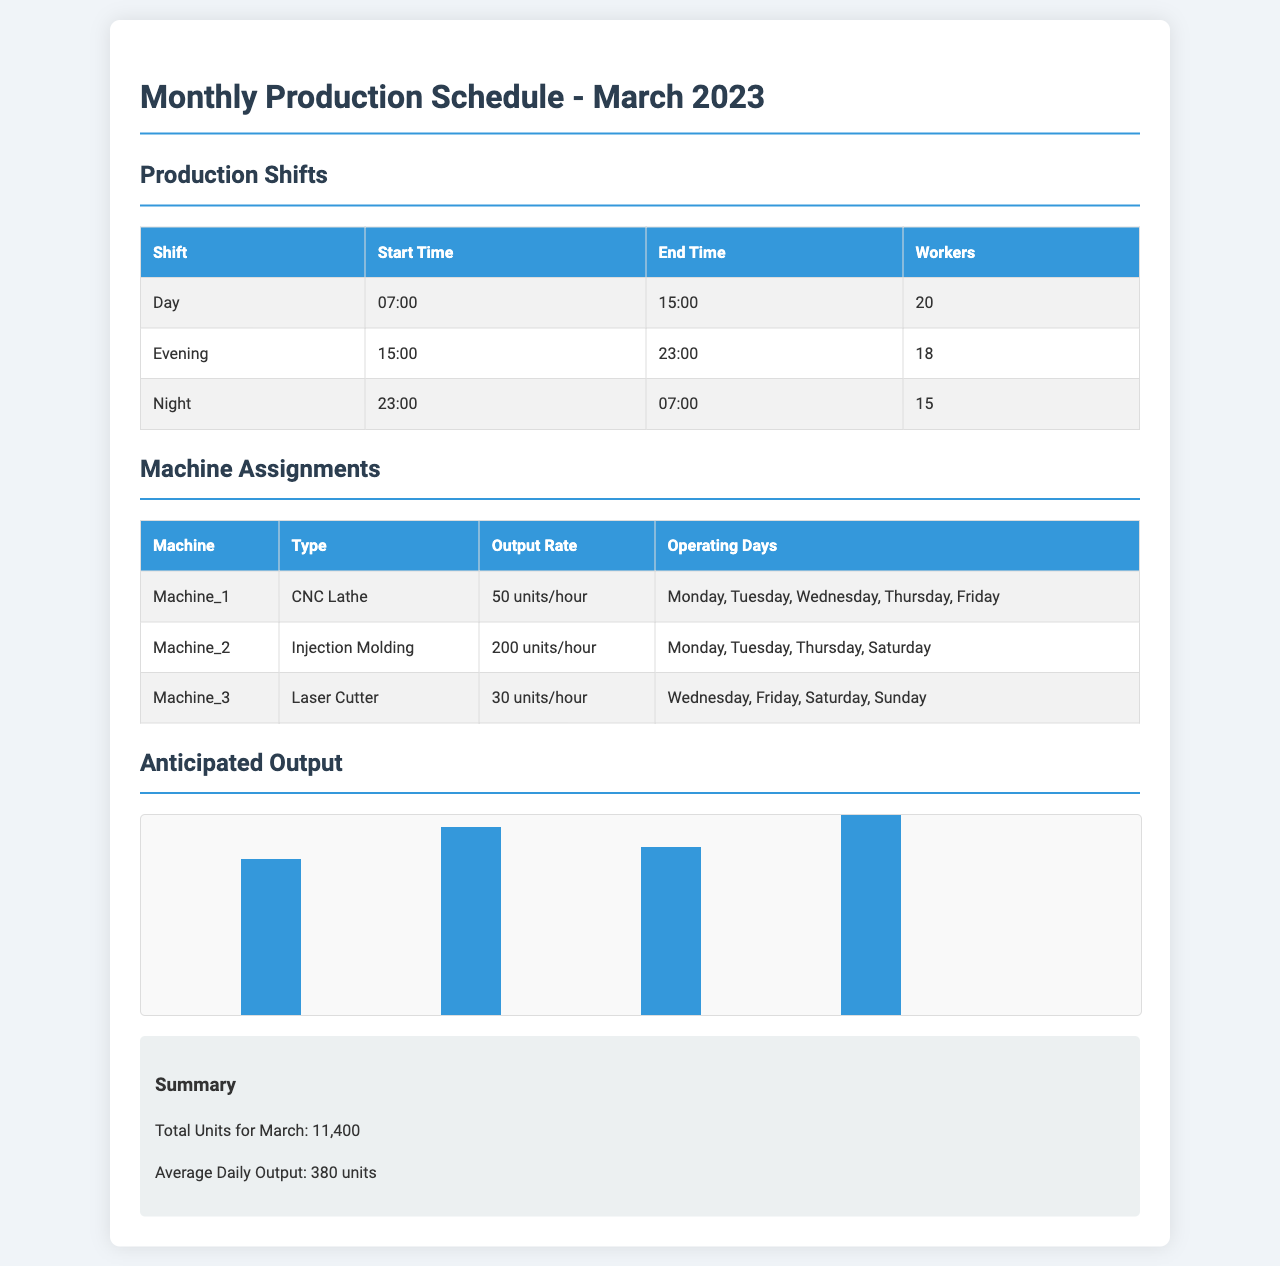What is the start time of the Day shift? The start time of the Day shift is listed in the Production Shifts section.
Answer: 07:00 How many workers are assigned to the Evening shift? The number of workers for the Evening shift is provided in the Production Shifts table.
Answer: 18 What is the output rate of Machine_2? The output rate for Machine_2 is found in the Machine Assignments table.
Answer: 200 units/hour On which days does Machine_3 operate? The operating days for Machine_3 are specified in the Machine Assignments section.
Answer: Wednesday, Friday, Saturday, Sunday What is the total output for March? The total output for March is provided in the Summary section of the document.
Answer: 11,400 Which shift has the least number of workers assigned? This requires comparing the number of workers across different shifts listed in the Production Shifts table.
Answer: Night How many units are anticipated in Week 4? The anticipated output for Week 4 is labeled on the output chart.
Answer: 3200 units Which machine type has the highest output rate? By comparing the output rates in the Machine Assignments table, we can identify which machine type has the highest rate.
Answer: Injection Molding What is the average daily output? The average daily output is mentioned in the Summary section of the document.
Answer: 380 units 